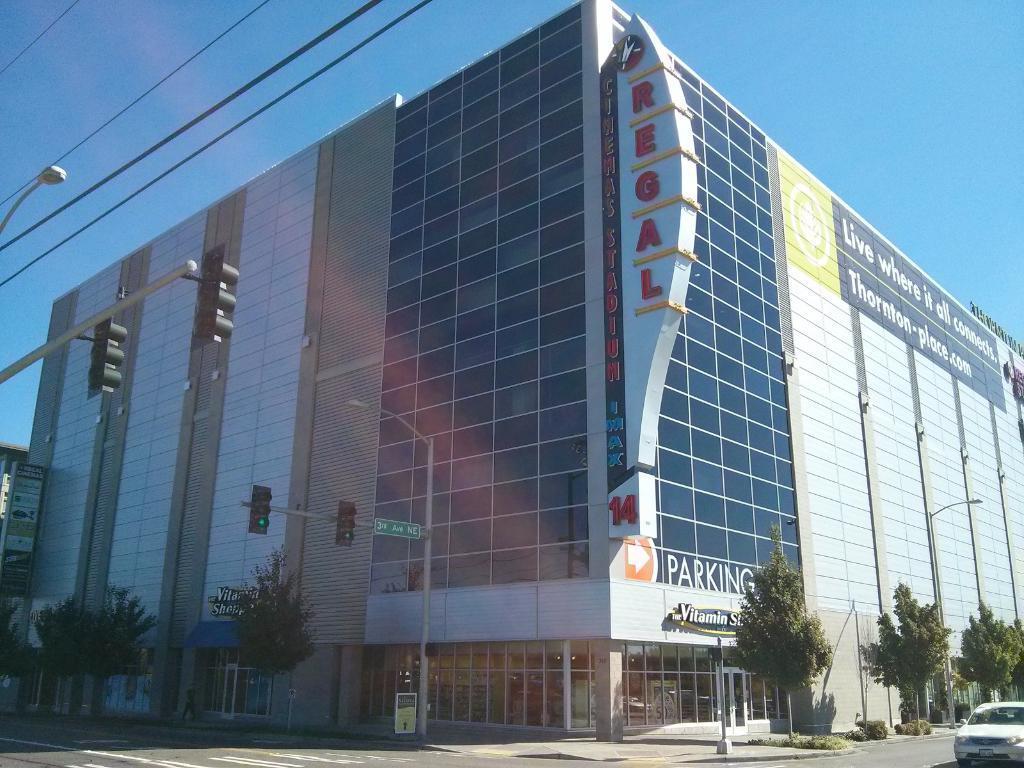Describe this image in one or two sentences. In this image we can see a building, trees, shrubs, traffic signal light poles, wires, hoarding and also a vehicle passing on the road. We can also see the sky. 